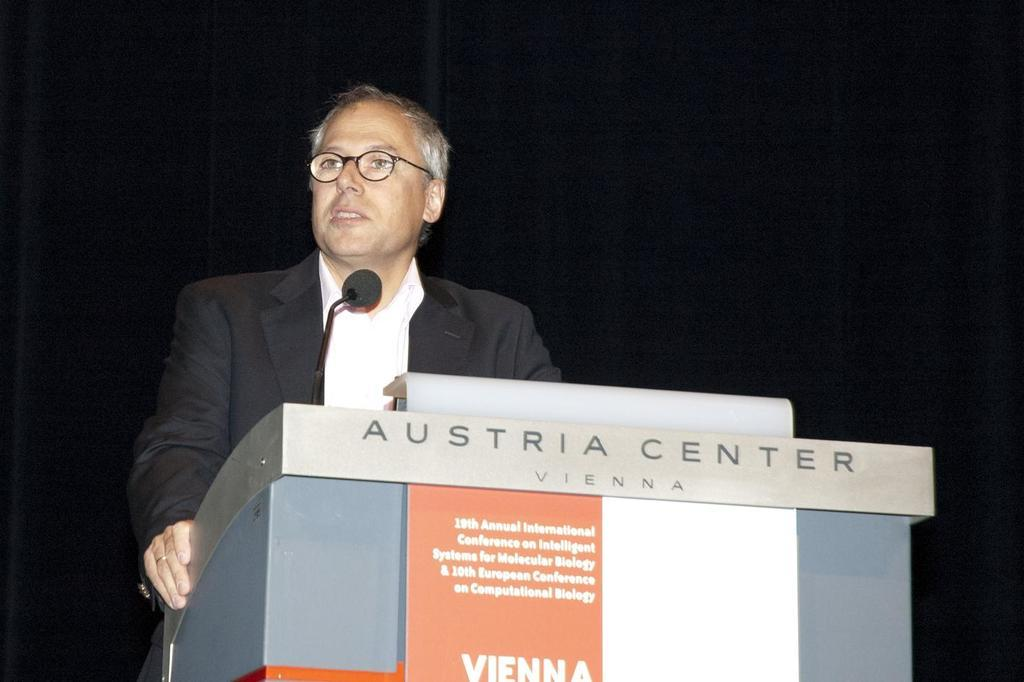What is the person in the image doing near the podium? The person is standing near a podium and holding a microphone. What might the person be using the microphone for? The person might be using the microphone for speaking or presenting. What is the color of the background in the image? The background of the image is black in color. What type of pest can be seen crawling on the cushion in the image? There is no cushion or pest present in the image. 